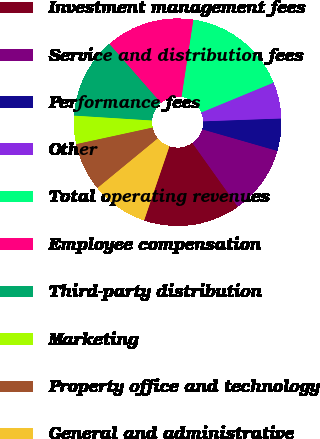Convert chart. <chart><loc_0><loc_0><loc_500><loc_500><pie_chart><fcel>Investment management fees<fcel>Service and distribution fees<fcel>Performance fees<fcel>Other<fcel>Total operating revenues<fcel>Employee compensation<fcel>Third-party distribution<fcel>Marketing<fcel>Property office and technology<fcel>General and administrative<nl><fcel>15.09%<fcel>10.69%<fcel>5.03%<fcel>5.66%<fcel>16.35%<fcel>13.84%<fcel>12.58%<fcel>4.4%<fcel>7.55%<fcel>8.81%<nl></chart> 